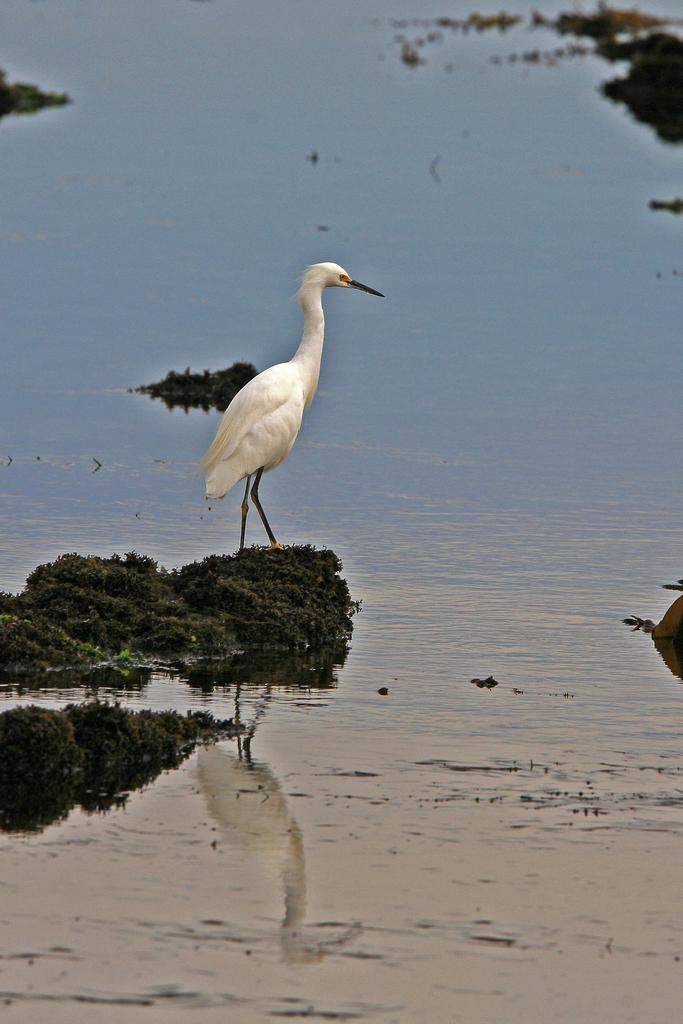What type of animal can be seen in the image? There is a bird in the image. What is the primary element in which the bird is situated? There is water visible in the image, and the bird is likely in or near the water. What color is the bird's eye in the image? The facts provided do not mention the color of the bird's eye, and there is no information about the bird's eye in the image. 